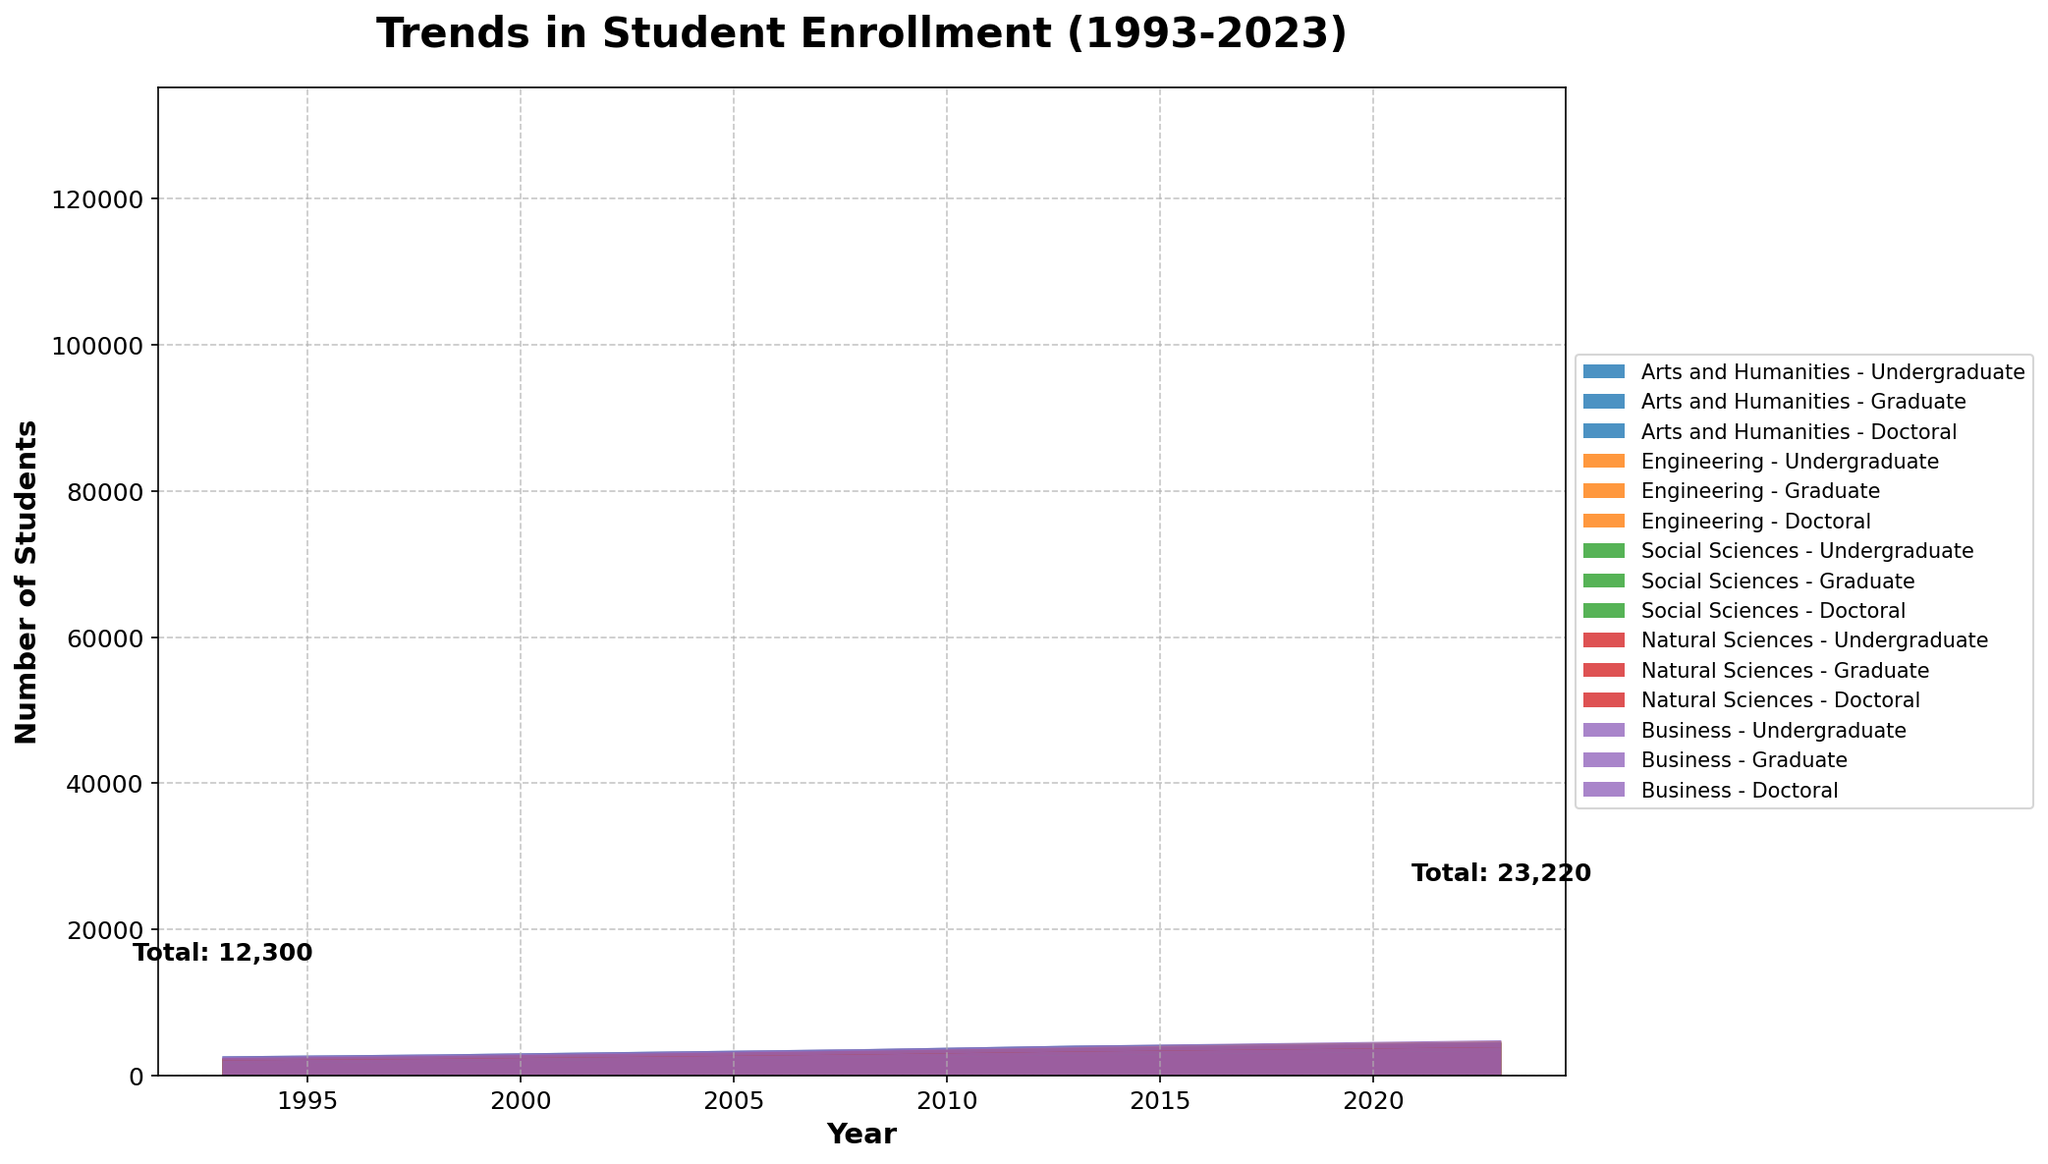What is the title of the graph? The title of the graph is usually displayed at the top center of the figure. It often summarizes what the graph represents. In this case, the title is "Trends in Student Enrollment (1993-2023)"
Answer: Trends in Student Enrollment (1993-2023) What do the X and Y axes represent? The X-axis typically represents the variable along a horizontal line, while the Y-axis represents the variable along a vertical line. In this figure, the X-axis represents "Year," and the Y-axis represents "Number of Students"
Answer: Year, Number of Students Which faculty shows the highest undergraduate enrollment in 2023? To find this information, look at the streams for each faculty in 2023 and identify which stream has the highest value for undergraduate enrollment. The faculty with the highest stream will be the one with the highest enrollment. The Business faculty has the highest undergraduate enrollment in 2023.
Answer: Business Which level of enrollment saw the smallest overall increase from 1993 to 2023 and in which faculty? To determine this, observe the streams corresponding to the different levels (Undergraduate, Graduate, Doctoral) for each faculty in 1993 and 2023. Calculate the increase for each level within each faculty over these years and compare. The doctoral level in Social Sciences saw the smallest overall increase.
Answer: Doctoral in Social Sciences How has the enrollment in doctoral programs changed from 1993 to 2023 across all faculties? To examine this, locate the streams representing doctoral enrollment for each faculty in 1993 and in 2023. By comparing these streams, we can determine the trend. All faculties show an increase in doctoral enrollment, though the specific increase varies.
Answer: Increased overall Which faculty had the lowest graduate enrollment in 2008? To answer this, examine the graduate enrollment streams for all faculties in 2008 and identify which one is the lowest. Look for the smallest stream value in that year.
Answer: Social Sciences Compare the trends in undergraduate enrollment for Arts and Humanities and Engineering from 1993 to 2023. Observe the undergraduate streams for both Arts and Humanities and Engineering over the years. Compare the shapes and heights of these streams to assess the trends. Both faculties show an increasing trend, but Arts and Humanities have seen a steadier and steeper increase compared to Engineering.
Answer: Both increased, Arts and Humanities increased more steadily In which year did the Business faculty surpass the 3000 mark in undergraduate enrollment? Examine the Business undergraduate stream and record the year when it first crosses the 3000-student mark. This occurs in the period represented on the X-axis.
Answer: 2013 Determine the total number of students enrolled in 2023 across all faculties. Sum the stream heights for all faculties across all levels (Undergraduate, Graduate, Doctoral) for the year 2023. This gives the total student enrollment for that year.
Answer: 22,970 How do the trends in graduate enrollments compare between Natural Sciences and Social Sciences from 1993 to 2023? Analyze the graduate streams for Natural Sciences and Social Sciences over the specified years. Compare and contrast the trends by examining the shapes and heights of these streams. Both faculties show an increase, but Natural Sciences have a relatively larger increase compared to Social Sciences.
Answer: Both increased, Natural Sciences more than Social Sciences 